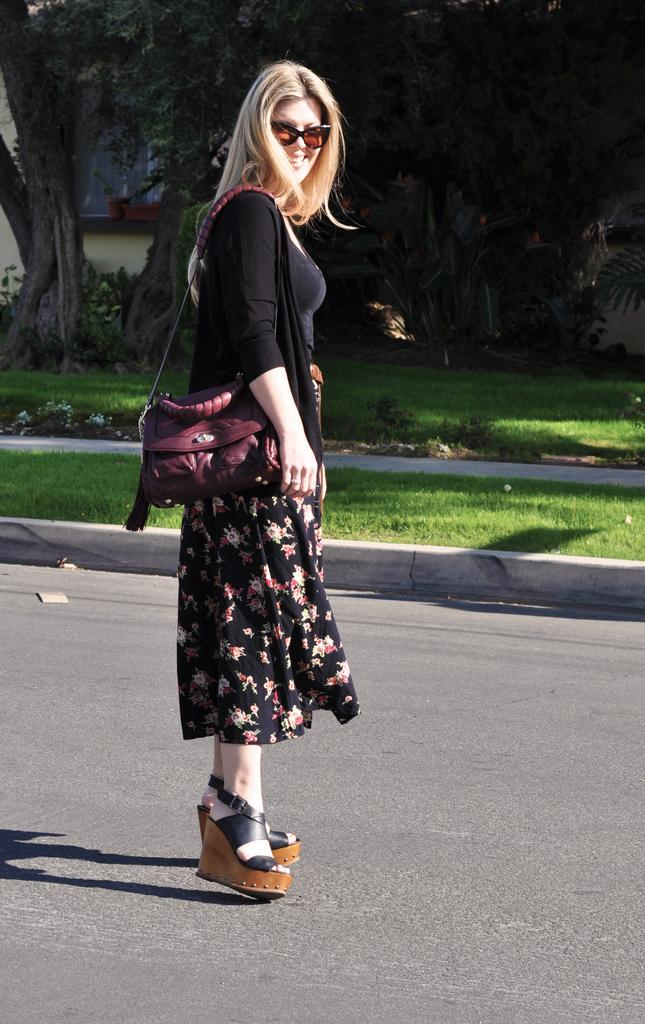What is the woman in the image doing? The woman is standing on the road. What is the woman carrying in the image? The woman is wearing a bag. What can be seen in the background of the image? There is a wall, trees, and grass visible in the image. What book is the woman reading while standing on the road? There is no book visible in the image, and the woman is not reading anything. 